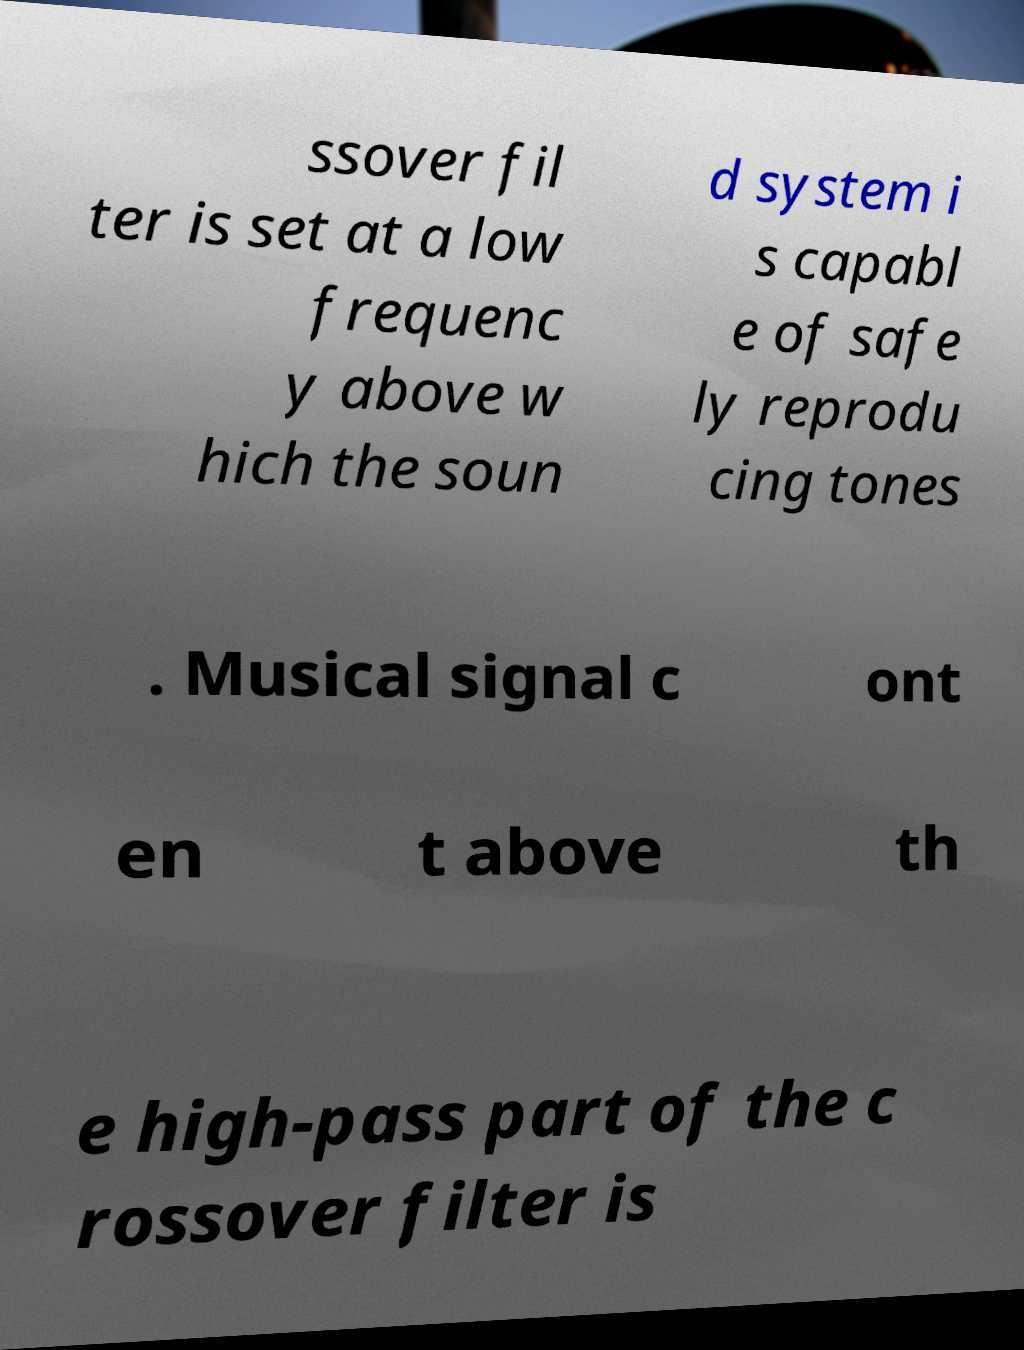I need the written content from this picture converted into text. Can you do that? ssover fil ter is set at a low frequenc y above w hich the soun d system i s capabl e of safe ly reprodu cing tones . Musical signal c ont en t above th e high-pass part of the c rossover filter is 